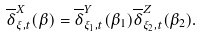Convert formula to latex. <formula><loc_0><loc_0><loc_500><loc_500>\overline { \delta } ^ { X } _ { \xi , t } ( \beta ) = \overline { \delta } ^ { Y } _ { \xi _ { 1 } , t } ( \beta _ { 1 } ) \overline { \delta } ^ { Z } _ { \xi _ { 2 } , t } ( \beta _ { 2 } ) .</formula> 